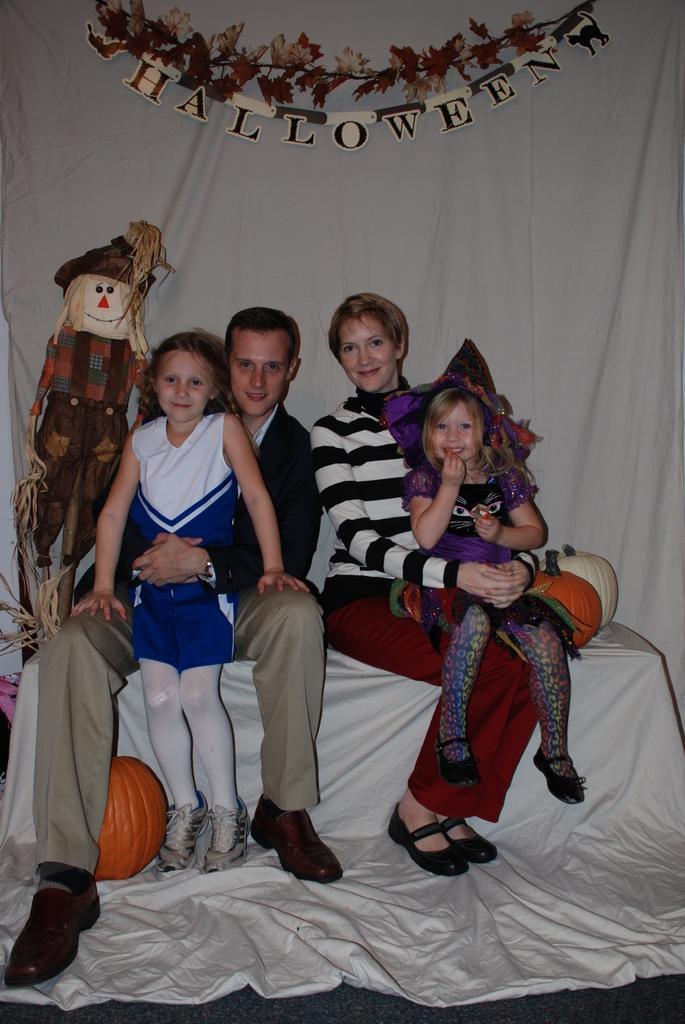Could you give a brief overview of what you see in this image? In this image, we can see a group of people wearing clothes and sitting on the bench in front of the curtain. There is a doll on the left side of the image. There is a decor at the top of the image. There is a pumpkin in the bottom left and on the right side of the image. 